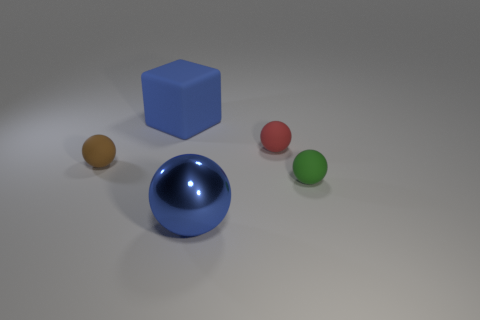Could you describe the composition of the objects in the image? Certainly. The image features a central composition characterized by a large blue cube in the middle, flanked by four spheres of varying colors - mustard, blue, red, and green. The placement of these objects appears deliberate, with the blue sphere's position mirroring that of the cube, while the other spheres are evenly spaced, creating a balanced yet dynamic arrangement. 